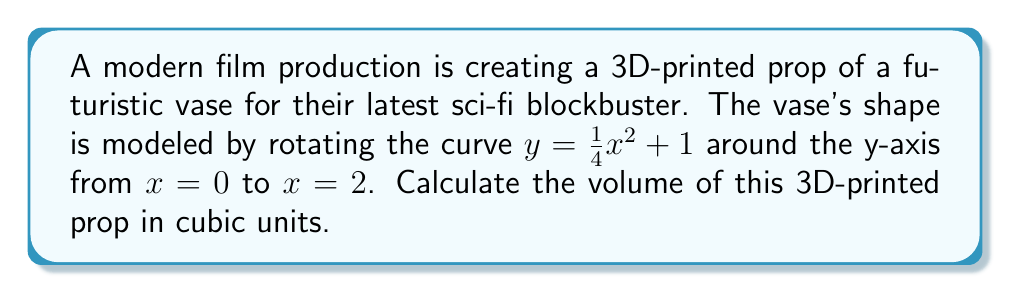Help me with this question. To find the volume of this 3D-printed prop, we need to use the method of integration for volumes of revolution. Since we're rotating around the y-axis, we'll use the washer method.

Step 1: Set up the integral
The volume is given by the formula:
$$V = \pi \int_a^b [R(y)]^2 dy$$
where $R(y)$ is the radius function.

Step 2: Find the radius function
We need to solve the equation for x:
$$y = \frac{1}{4}x^2 + 1$$
$$x^2 = 4(y-1)$$
$$x = 2\sqrt{y-1}$$

So, $R(y) = 2\sqrt{y-1}$

Step 3: Determine the limits of integration
The bottom limit is when $x = 0$, so $y = 1$
The top limit is when $x = 2$, so $y = \frac{1}{4}(2)^2 + 1 = 2$

Step 4: Set up and evaluate the integral
$$V = \pi \int_1^2 [2\sqrt{y-1}]^2 dy$$
$$V = 4\pi \int_1^2 (y-1) dy$$
$$V = 4\pi [\frac{1}{2}y^2 - y]_1^2$$
$$V = 4\pi [(\frac{1}{2}(2)^2 - 2) - (\frac{1}{2}(1)^2 - 1)]$$
$$V = 4\pi [2 - 2 - \frac{1}{2} + 1]$$
$$V = 4\pi [\frac{1}{2}]$$
$$V = 2\pi$$

Therefore, the volume of the 3D-printed prop is $2\pi$ cubic units.
Answer: $2\pi$ cubic units 